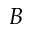Convert formula to latex. <formula><loc_0><loc_0><loc_500><loc_500>B</formula> 